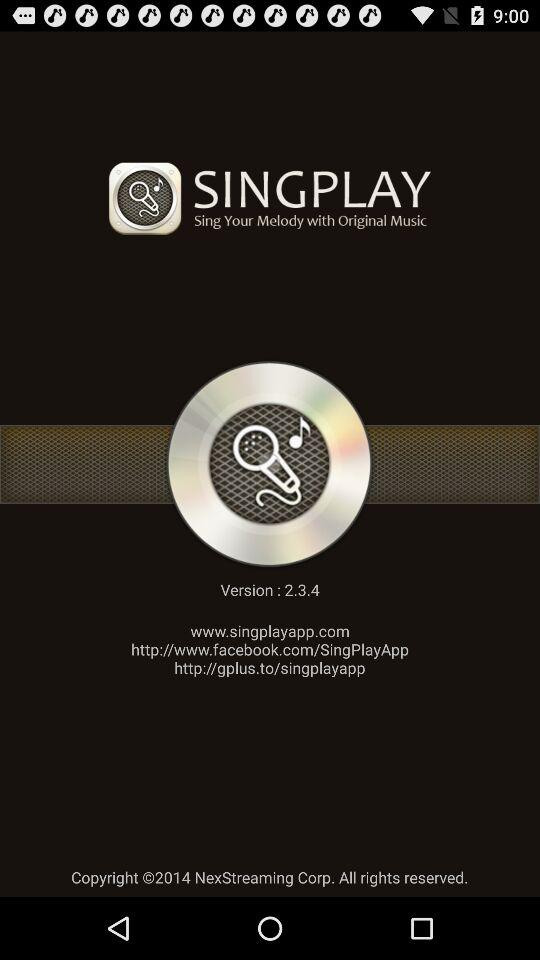What is the build number?
When the provided information is insufficient, respond with <no answer>. <no answer> 